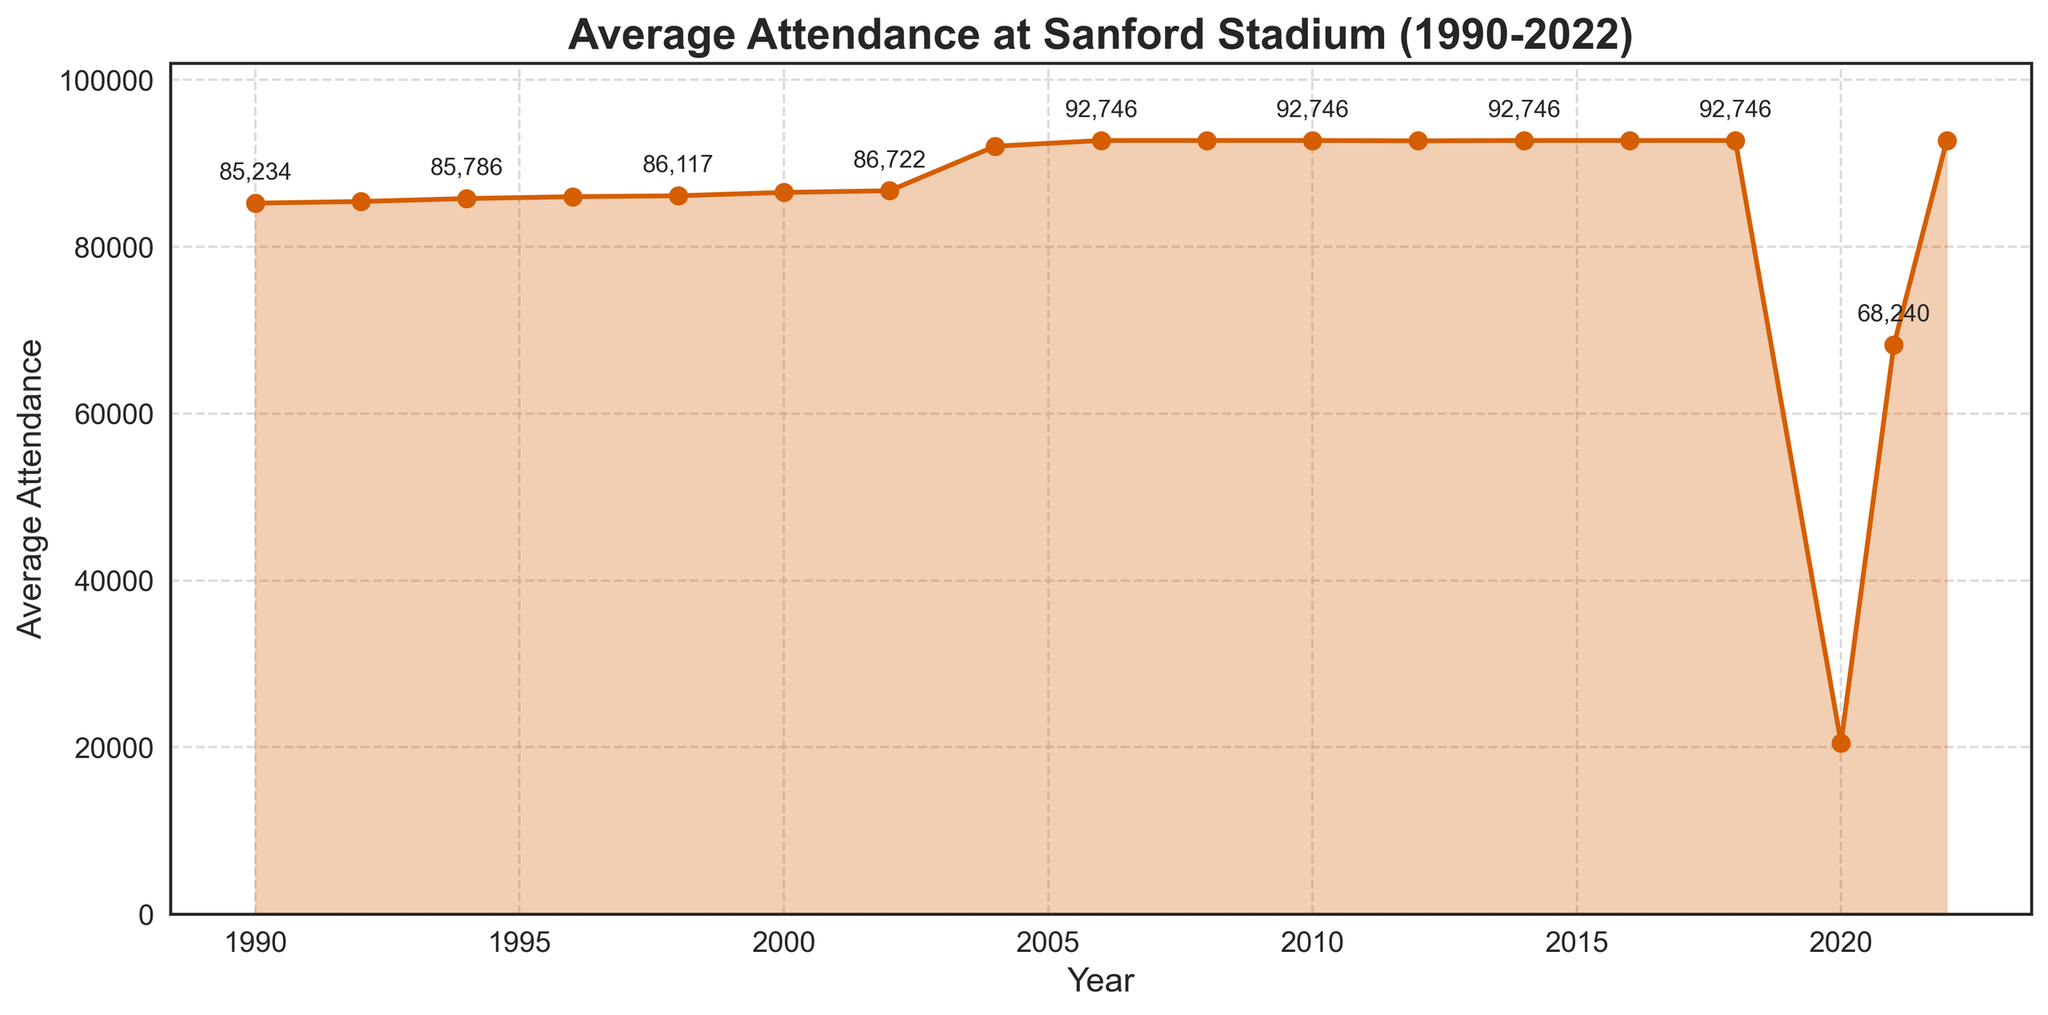what year had the highest average attendance? The figure shows the line chart for average attendance between 1990 and 2022, with the highest value being approximately 92746, which multiple years achieve. The latest year with 92746 is 2022.
Answer: 2022 how did the average attendance in 1990 compare to 2000? By reading the figure, the average attendance in 1990 was 85234, while in 2000, it was 86520. 86520 - 85234 = 1286, so 2000 had 1286 more attendees on average than 1990.
Answer: 86520 (2000) was higher by 1286 what was the percent decrease in average attendance from 2019 to 2020? The average attendance in 2019 was 92746 (visual data point for the year before 2020), and in 2020 it dropped drastically to 20524. The percent decrease formula is ((92746 - 20524) / 92746) * 100. This results in approximately a 77.88% decrease.
Answer: 77.88% which year had the lowest average attendance? The figure shows the lowest attendance was in 2020 with a value of 20524.
Answer: 2020 what trend do you observe in average attendance between 2004 and 2010? From the visual line chart, the average attendance markedly increased in 2004 to a high value of around 92058 and then remained relatively stable at around 92746 from 2006 to 2010.
Answer: Stable, high attendance what was the total average attendance from 2016 to 2022? The visual data points for 2016, 2018, 2020, 2021, and 2022 are 92746, 92746, 20524, 68240, and 92746 respectively. Summing these numbers gives: 92746 + 92746 + 20524 + 68240 + 92746 = 367202
Answer: 367202 how did the average attendance change from 1992 to 1994? The figure shows the average attendance was 85432 in 1992 and 85786 in 1994. The change is 85786 - 85432 = 354, indicating a small increase over these two years.
Answer: Increased by 354 how many years showed the maximum average attendance of 92746? By examining the line chart, the maximum value of 92746 appears for the years 2006, 2008, 2010, 2014, 2016, 2018, 2022, and visually these comprise 7 data points.
Answer: 7 years 